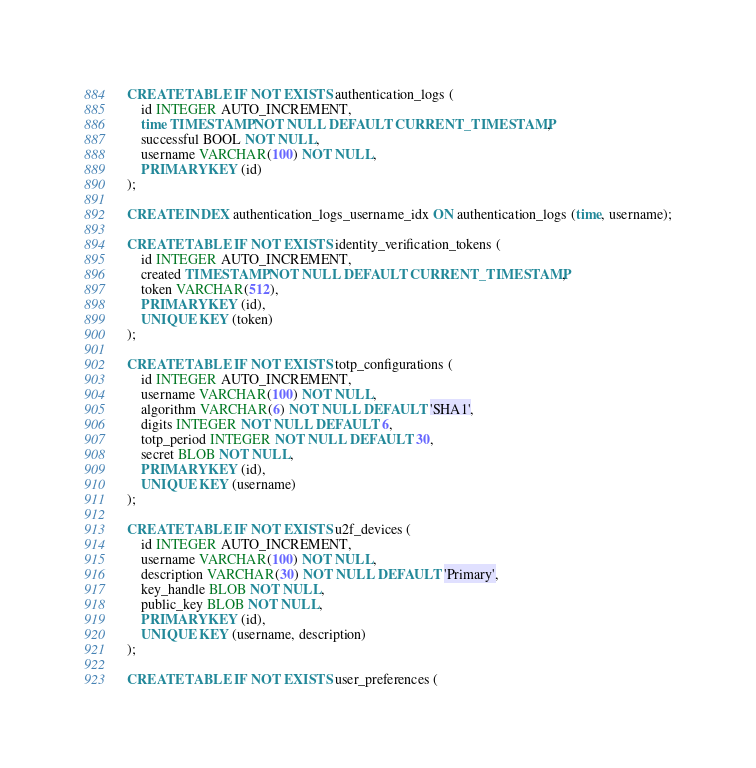Convert code to text. <code><loc_0><loc_0><loc_500><loc_500><_SQL_>CREATE TABLE IF NOT EXISTS authentication_logs (
    id INTEGER AUTO_INCREMENT,
    time TIMESTAMP NOT NULL DEFAULT CURRENT_TIMESTAMP,
    successful BOOL NOT NULL,
    username VARCHAR(100) NOT NULL,
    PRIMARY KEY (id)
);

CREATE INDEX authentication_logs_username_idx ON authentication_logs (time, username);

CREATE TABLE IF NOT EXISTS identity_verification_tokens (
    id INTEGER AUTO_INCREMENT,
    created TIMESTAMP NOT NULL DEFAULT CURRENT_TIMESTAMP,
    token VARCHAR(512),
    PRIMARY KEY (id),
    UNIQUE KEY (token)
);

CREATE TABLE IF NOT EXISTS totp_configurations (
    id INTEGER AUTO_INCREMENT,
    username VARCHAR(100) NOT NULL,
    algorithm VARCHAR(6) NOT NULL DEFAULT 'SHA1',
    digits INTEGER NOT NULL DEFAULT 6,
    totp_period INTEGER NOT NULL DEFAULT 30,
    secret BLOB NOT NULL,
    PRIMARY KEY (id),
    UNIQUE KEY (username)
);

CREATE TABLE IF NOT EXISTS u2f_devices (
    id INTEGER AUTO_INCREMENT,
    username VARCHAR(100) NOT NULL,
    description VARCHAR(30) NOT NULL DEFAULT 'Primary',
    key_handle BLOB NOT NULL,
    public_key BLOB NOT NULL,
    PRIMARY KEY (id),
    UNIQUE KEY (username, description)
);

CREATE TABLE IF NOT EXISTS user_preferences (</code> 